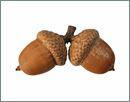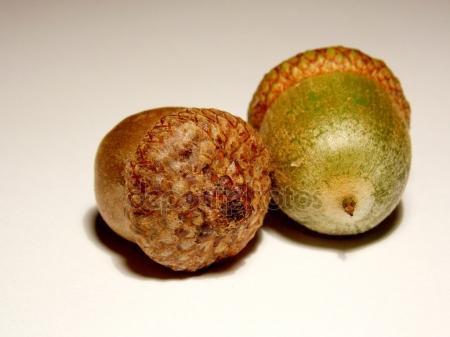The first image is the image on the left, the second image is the image on the right. Analyze the images presented: Is the assertion "The left and right image contains the same number of real acorns." valid? Answer yes or no. Yes. The first image is the image on the left, the second image is the image on the right. Assess this claim about the two images: "Each image contains exactly two acorns with their caps on, and at least one of the images features acorns with caps back-to-back and joined at the stem top.". Correct or not? Answer yes or no. Yes. 